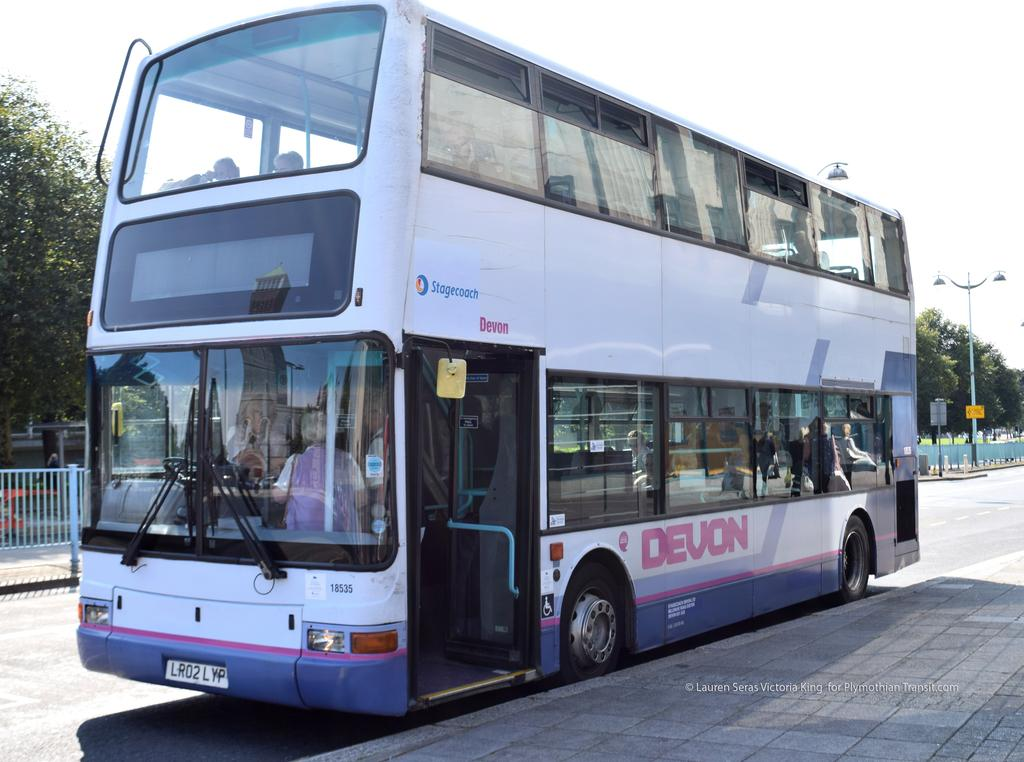Provide a one-sentence caption for the provided image. A Devon two level bus is parked on the side of a road. 